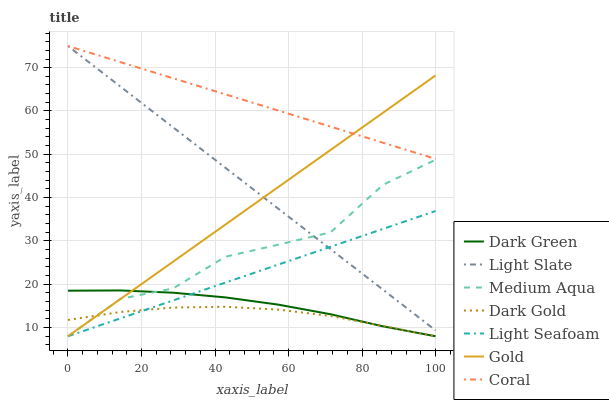Does Dark Gold have the minimum area under the curve?
Answer yes or no. Yes. Does Light Slate have the minimum area under the curve?
Answer yes or no. No. Does Light Slate have the maximum area under the curve?
Answer yes or no. No. Is Medium Aqua the roughest?
Answer yes or no. Yes. Is Dark Gold the smoothest?
Answer yes or no. No. Is Dark Gold the roughest?
Answer yes or no. No. Does Light Slate have the lowest value?
Answer yes or no. No. Does Dark Gold have the highest value?
Answer yes or no. No. Is Dark Green less than Coral?
Answer yes or no. Yes. Is Coral greater than Medium Aqua?
Answer yes or no. Yes. Does Dark Green intersect Coral?
Answer yes or no. No. 